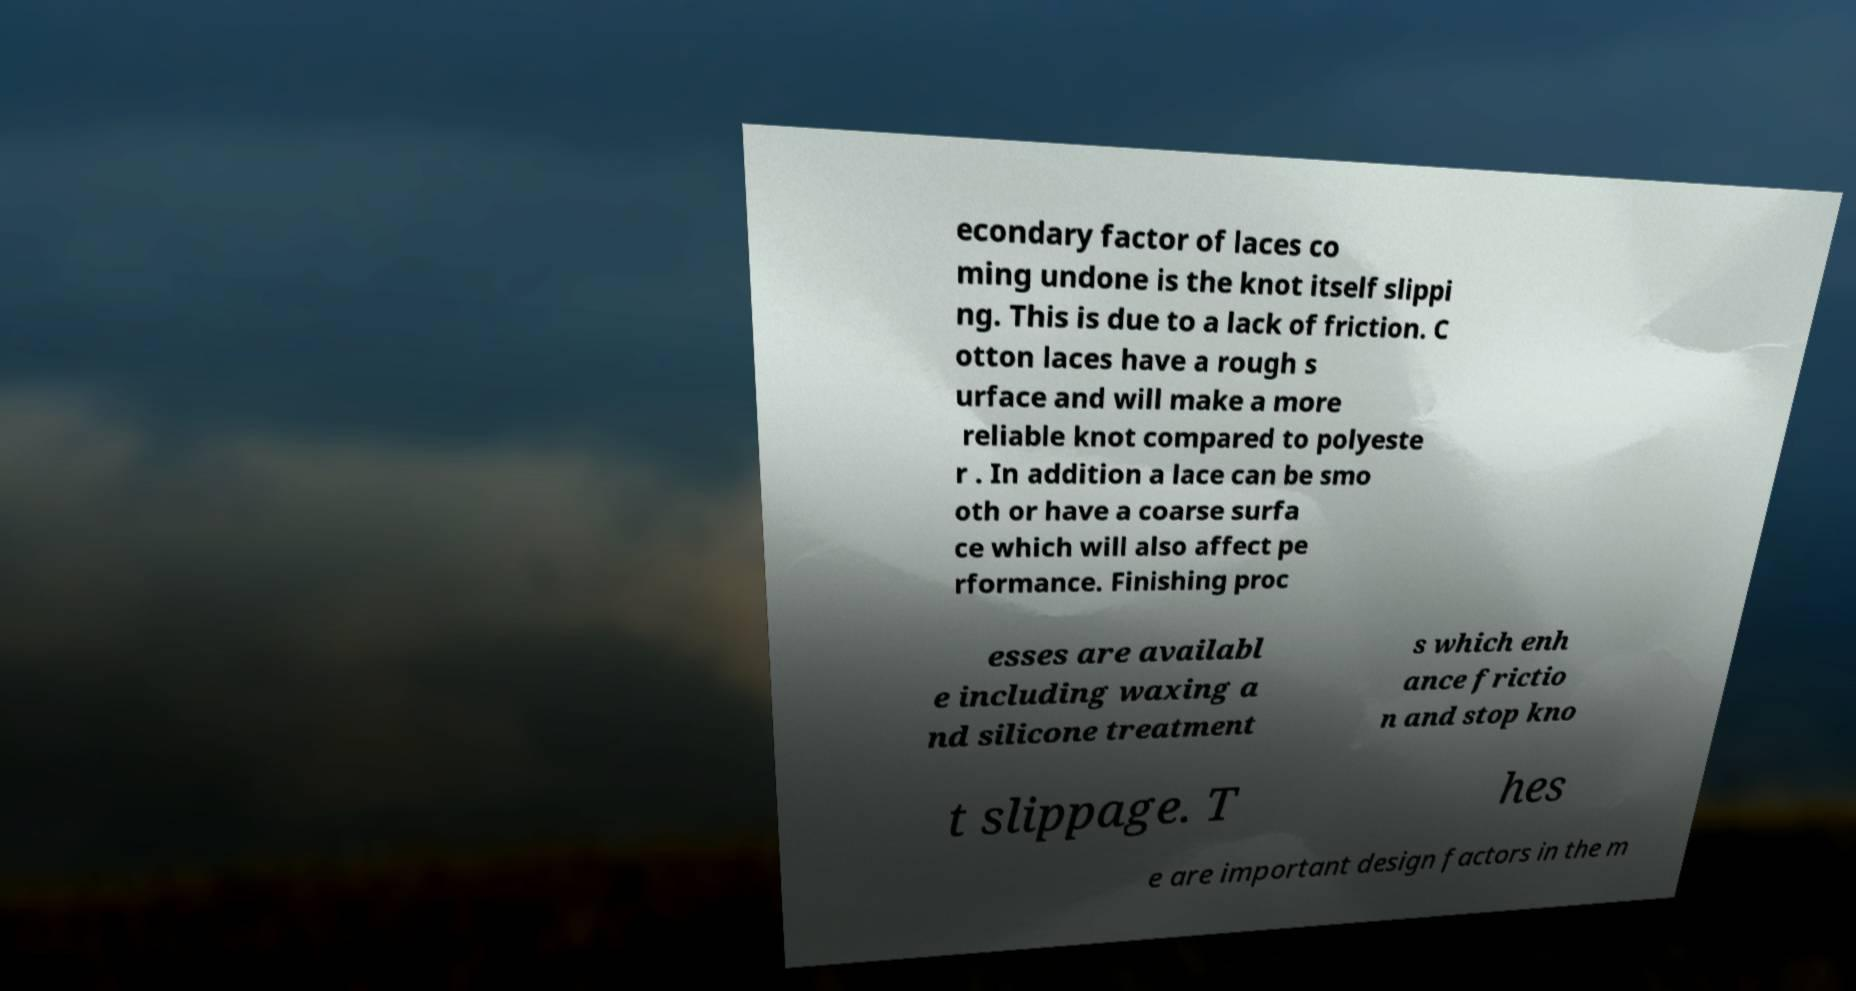For documentation purposes, I need the text within this image transcribed. Could you provide that? econdary factor of laces co ming undone is the knot itself slippi ng. This is due to a lack of friction. C otton laces have a rough s urface and will make a more reliable knot compared to polyeste r . In addition a lace can be smo oth or have a coarse surfa ce which will also affect pe rformance. Finishing proc esses are availabl e including waxing a nd silicone treatment s which enh ance frictio n and stop kno t slippage. T hes e are important design factors in the m 